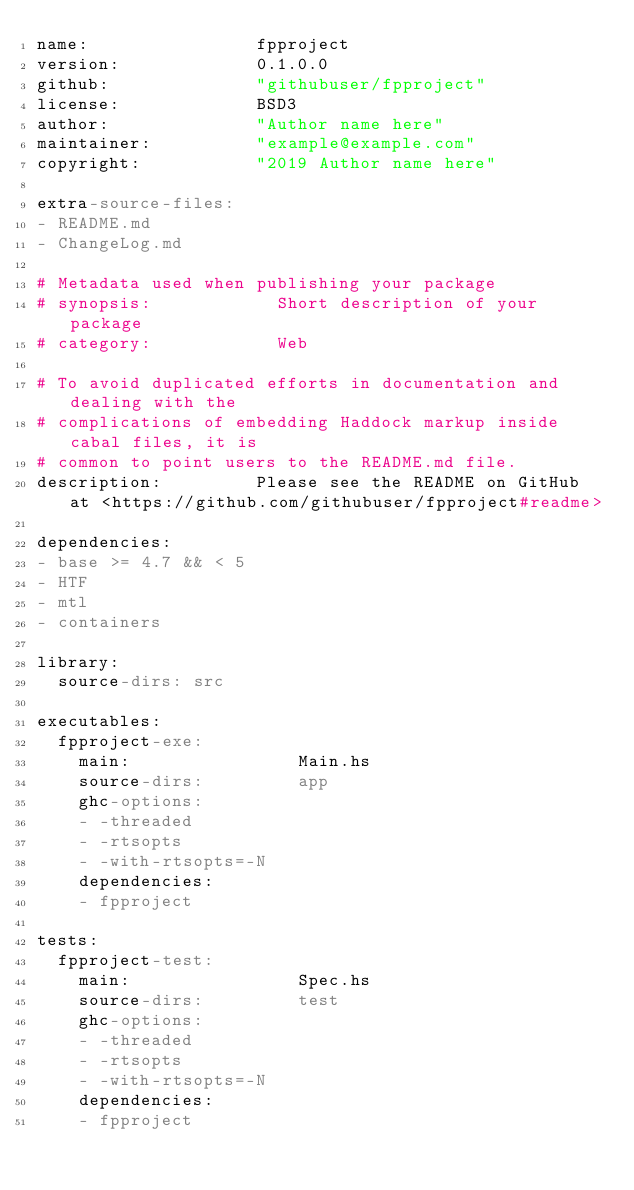Convert code to text. <code><loc_0><loc_0><loc_500><loc_500><_YAML_>name:                fpproject
version:             0.1.0.0
github:              "githubuser/fpproject"
license:             BSD3
author:              "Author name here"
maintainer:          "example@example.com"
copyright:           "2019 Author name here"

extra-source-files:
- README.md
- ChangeLog.md

# Metadata used when publishing your package
# synopsis:            Short description of your package
# category:            Web

# To avoid duplicated efforts in documentation and dealing with the
# complications of embedding Haddock markup inside cabal files, it is
# common to point users to the README.md file.
description:         Please see the README on GitHub at <https://github.com/githubuser/fpproject#readme>

dependencies:
- base >= 4.7 && < 5
- HTF
- mtl
- containers

library:
  source-dirs: src

executables:
  fpproject-exe:
    main:                Main.hs
    source-dirs:         app
    ghc-options:
    - -threaded
    - -rtsopts
    - -with-rtsopts=-N
    dependencies:
    - fpproject

tests:
  fpproject-test:
    main:                Spec.hs
    source-dirs:         test
    ghc-options:
    - -threaded
    - -rtsopts
    - -with-rtsopts=-N
    dependencies:
    - fpproject
</code> 